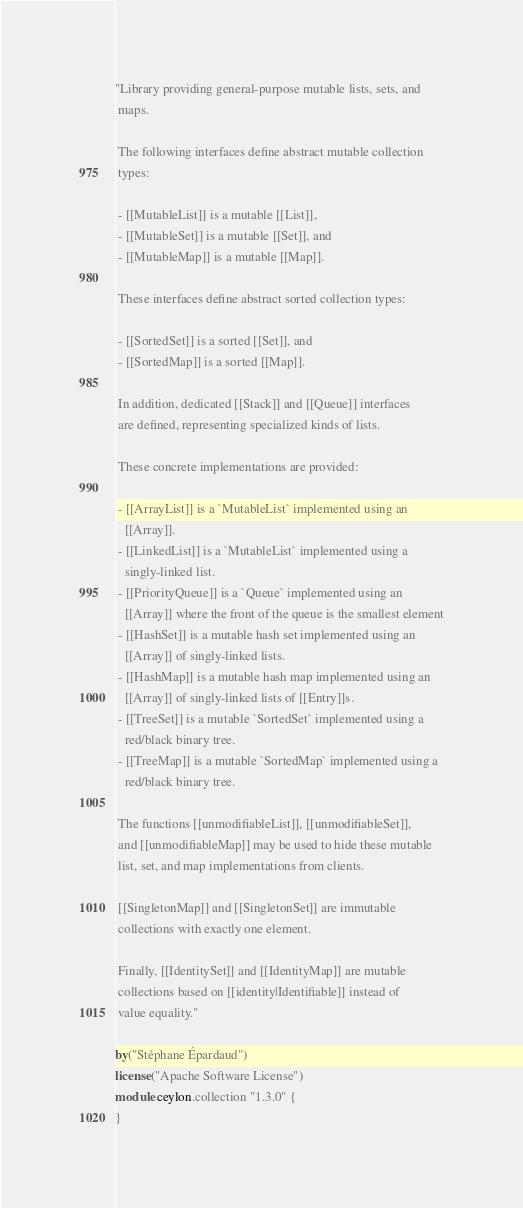<code> <loc_0><loc_0><loc_500><loc_500><_Ceylon_>"Library providing general-purpose mutable lists, sets, and 
 maps.
 
 The following interfaces define abstract mutable collection 
 types:
 
 - [[MutableList]] is a mutable [[List]],
 - [[MutableSet]] is a mutable [[Set]], and
 - [[MutableMap]] is a mutable [[Map]].
 
 These interfaces define abstract sorted collection types:
 
 - [[SortedSet]] is a sorted [[Set]], and
 - [[SortedMap]] is a sorted [[Map]].
 
 In addition, dedicated [[Stack]] and [[Queue]] interfaces 
 are defined, representing specialized kinds of lists.
 
 These concrete implementations are provided:
 
 - [[ArrayList]] is a `MutableList` implemented using an
   [[Array]].
 - [[LinkedList]] is a `MutableList` implemented using a
   singly-linked list.
 - [[PriorityQueue]] is a `Queue` implemented using an
   [[Array]] where the front of the queue is the smallest element
 - [[HashSet]] is a mutable hash set implemented using an 
   [[Array]] of singly-linked lists.
 - [[HashMap]] is a mutable hash map implemented using an 
   [[Array]] of singly-linked lists of [[Entry]]s.
 - [[TreeSet]] is a mutable `SortedSet` implemented using a 
   red/black binary tree.
 - [[TreeMap]] is a mutable `SortedMap` implemented using a 
   red/black binary tree.
 
 The functions [[unmodifiableList]], [[unmodifiableSet]],
 and [[unmodifiableMap]] may be used to hide these mutable 
 list, set, and map implementations from clients.
 
 [[SingletonMap]] and [[SingletonSet]] are immutable 
 collections with exactly one element.
 
 Finally, [[IdentitySet]] and [[IdentityMap]] are mutable
 collections based on [[identity|Identifiable]] instead of 
 value equality."

by("Stéphane Épardaud")
license("Apache Software License")
module ceylon.collection "1.3.0" {
}
</code> 